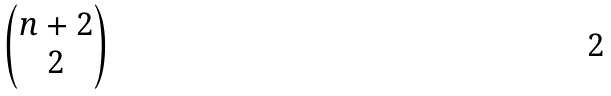Convert formula to latex. <formula><loc_0><loc_0><loc_500><loc_500>\begin{pmatrix} n + 2 \\ 2 \end{pmatrix}</formula> 